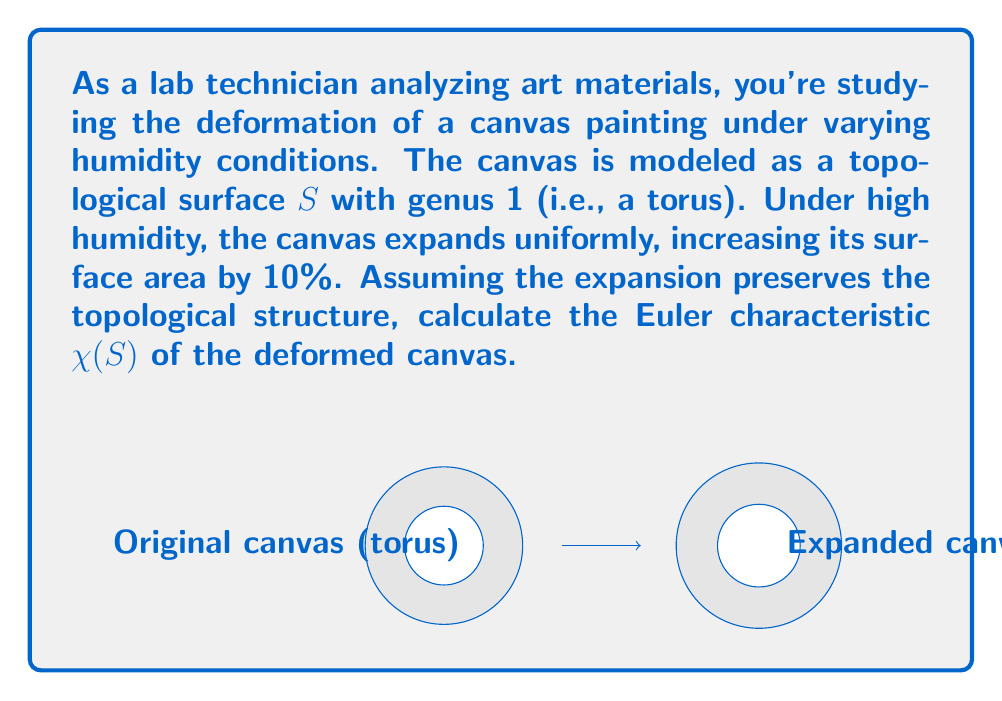Show me your answer to this math problem. Let's approach this step-by-step:

1) First, recall the definition of the Euler characteristic:
   $$\chi(S) = V - E + F$$
   where $V$ is the number of vertices, $E$ is the number of edges, and $F$ is the number of faces in a triangulation of the surface.

2) For a torus, the Euler characteristic is always 0, regardless of its size or how it's triangulated:
   $$\chi(\text{torus}) = 0$$

3) The key insight is that topological invariants, such as the Euler characteristic, remain unchanged under continuous deformations that don't change the fundamental structure of the surface.

4) The uniform expansion of the canvas due to humidity is a continuous deformation. It doesn't create any holes, tears, or fuse any parts of the canvas together. Therefore, it preserves the topological structure of the surface.

5) Since the topological structure is preserved, the Euler characteristic of the deformed canvas will be the same as that of the original canvas.

6) Therefore, the Euler characteristic of the deformed canvas is:
   $$\chi(S) = 0$$

This result holds true regardless of the magnitude of the expansion, as long as it's uniform and doesn't alter the topological structure of the canvas.
Answer: $\chi(S) = 0$ 